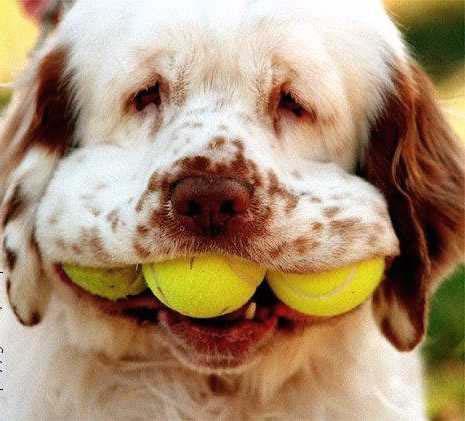What material is used to make the balls in the dogs mouth?
Choose the right answer and clarify with the format: 'Answer: answer
Rationale: rationale.'
Options: Leather, plastic, horsehair, rubber. Answer: rubber.
Rationale: The material is rubber. 